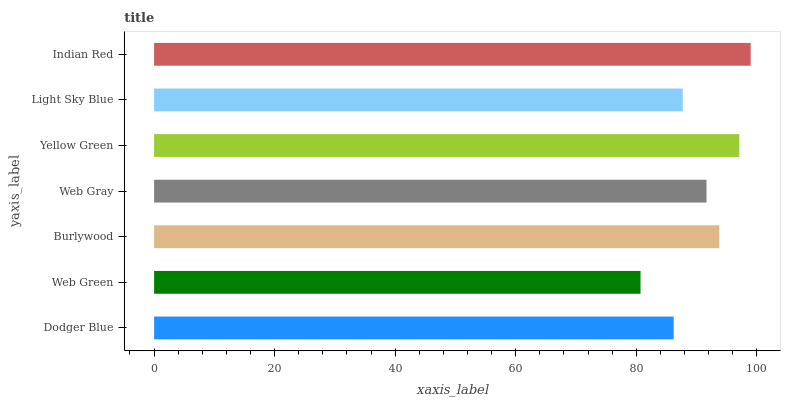Is Web Green the minimum?
Answer yes or no. Yes. Is Indian Red the maximum?
Answer yes or no. Yes. Is Burlywood the minimum?
Answer yes or no. No. Is Burlywood the maximum?
Answer yes or no. No. Is Burlywood greater than Web Green?
Answer yes or no. Yes. Is Web Green less than Burlywood?
Answer yes or no. Yes. Is Web Green greater than Burlywood?
Answer yes or no. No. Is Burlywood less than Web Green?
Answer yes or no. No. Is Web Gray the high median?
Answer yes or no. Yes. Is Web Gray the low median?
Answer yes or no. Yes. Is Indian Red the high median?
Answer yes or no. No. Is Dodger Blue the low median?
Answer yes or no. No. 